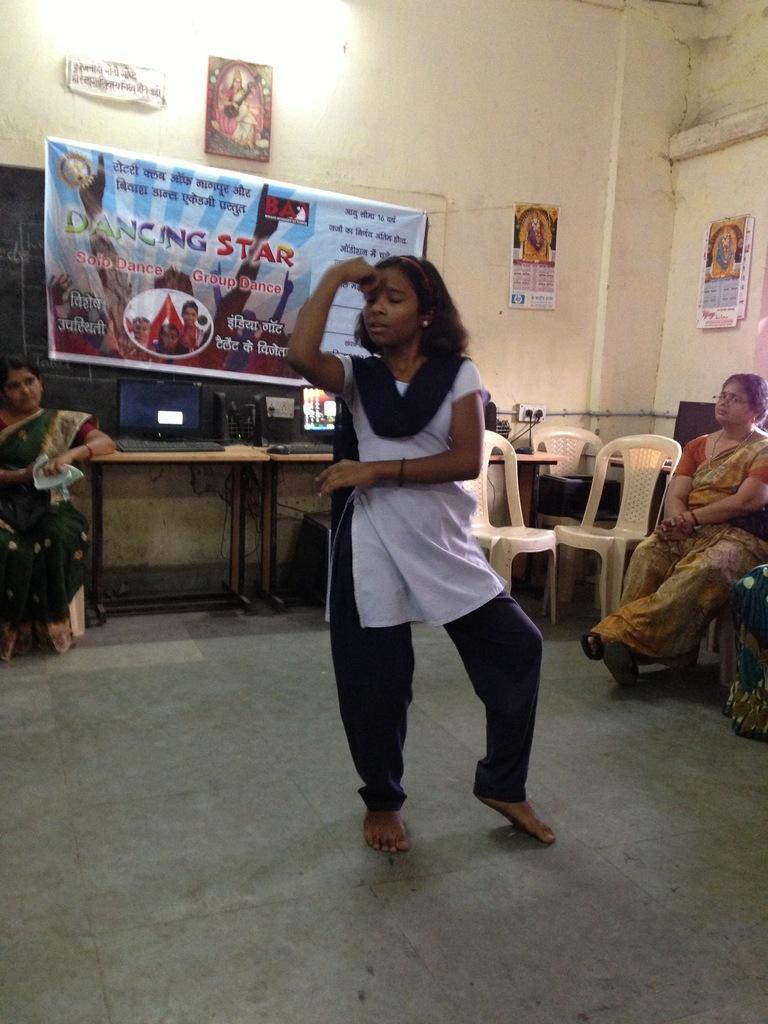Describe this image in one or two sentences. In this image we can see a girl is dancing on the floor, there are group of people sitting on the chairs, there is a table, and there are computers, keyboard on it, at the top there is a banner, there is a photo frame on the wall. 